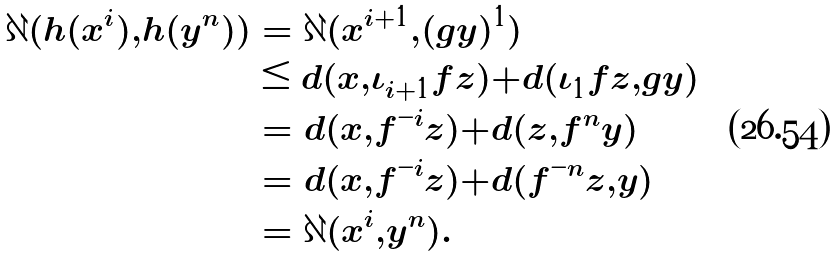Convert formula to latex. <formula><loc_0><loc_0><loc_500><loc_500>\partial ( h ( x ^ { i } ) , h ( y ^ { n } ) ) & = \partial ( x ^ { i + 1 } , ( g y ) ^ { 1 } ) \\ & \leq d ( x , \iota _ { i + 1 } f z ) + d ( \iota _ { 1 } f z , g y ) \\ & = d ( x , f ^ { - i } z ) + d ( z , f ^ { n } y ) \\ & = d ( x , f ^ { - i } z ) + d ( f ^ { - n } z , y ) \\ & = \partial ( x ^ { i } , y ^ { n } ) .</formula> 